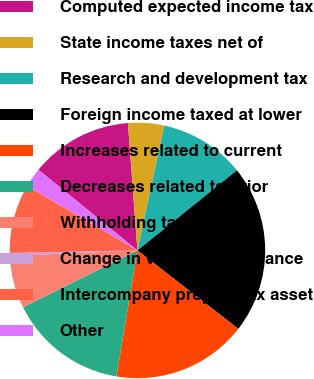Convert chart to OTSL. <chart><loc_0><loc_0><loc_500><loc_500><pie_chart><fcel>Computed expected income tax<fcel>State income taxes net of<fcel>Research and development tax<fcel>Foreign income taxed at lower<fcel>Increases related to current<fcel>Decreases related to prior<fcel>Withholding taxes<fcel>Change in valuation allowance<fcel>Intercompany prepaid tax asset<fcel>Other<nl><fcel>12.93%<fcel>4.56%<fcel>10.84%<fcel>21.31%<fcel>17.12%<fcel>15.03%<fcel>6.65%<fcel>0.37%<fcel>8.74%<fcel>2.46%<nl></chart> 